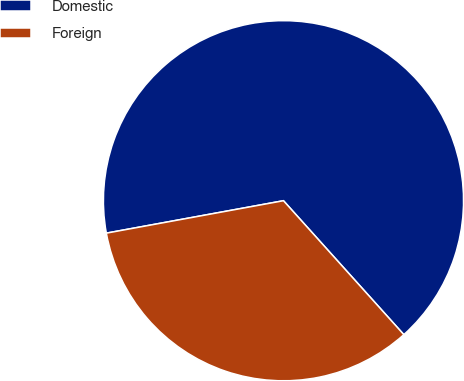Convert chart to OTSL. <chart><loc_0><loc_0><loc_500><loc_500><pie_chart><fcel>Domestic<fcel>Foreign<nl><fcel>66.23%<fcel>33.77%<nl></chart> 